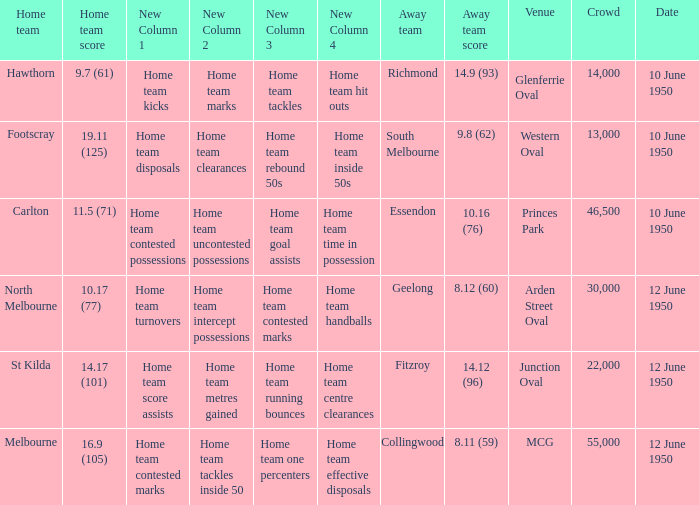What was the crowd when Melbourne was the home team? 55000.0. 